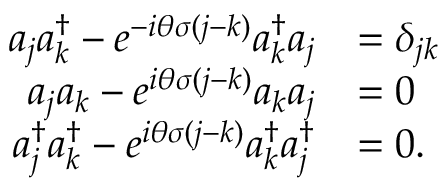Convert formula to latex. <formula><loc_0><loc_0><loc_500><loc_500>\begin{array} { r l } { { a } _ { j } { a } _ { k } ^ { \dagger } - e ^ { - i \theta \sigma ( j - k ) } { a } _ { k } ^ { \dagger } { a } _ { j } } & { = \delta _ { j k } } \\ { { a } _ { j } { a } _ { k } - e ^ { i \theta \sigma ( j - k ) } { a } _ { k } { a } _ { j } } & { = 0 } \\ { { a } _ { j } ^ { \dagger } { a } _ { k } ^ { \dagger } - e ^ { i \theta \sigma ( j - k ) } { a } _ { k } ^ { \dagger } { a } _ { j } ^ { \dagger } } & { = 0 . } \end{array}</formula> 